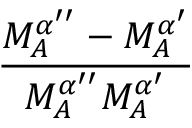Convert formula to latex. <formula><loc_0><loc_0><loc_500><loc_500>\frac { M _ { A } ^ { \alpha ^ { \prime \prime } } - M _ { A } ^ { \alpha ^ { \prime } } } { M _ { A } ^ { \alpha ^ { \prime \prime } } M _ { A } ^ { \alpha ^ { \prime } } }</formula> 